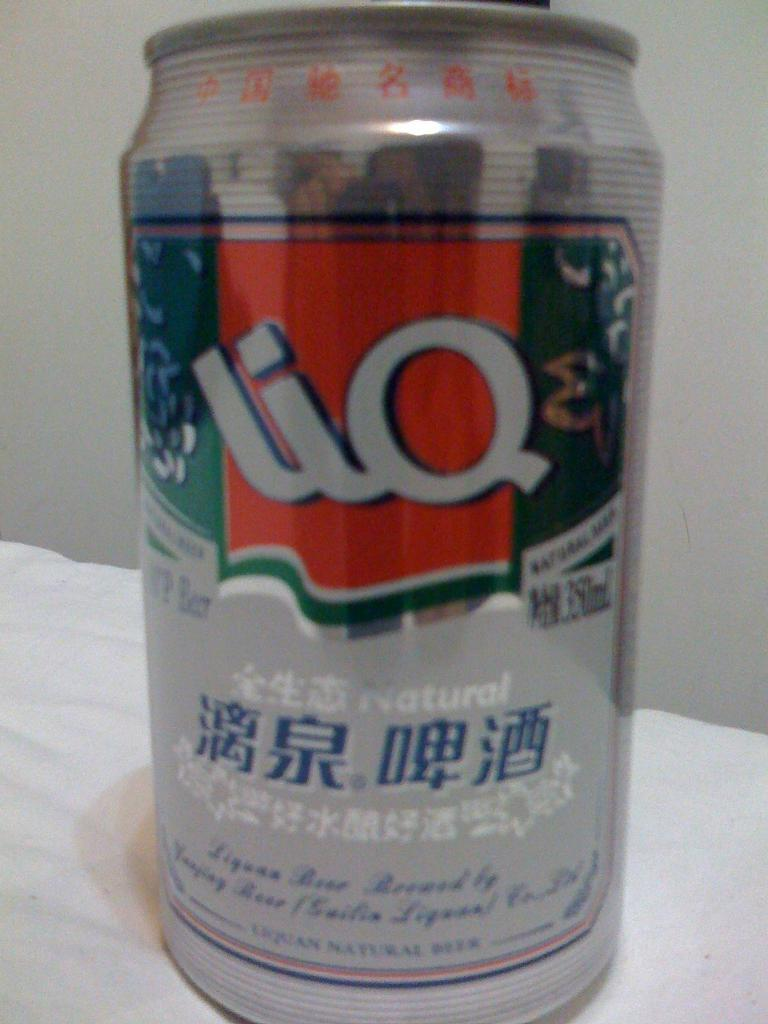<image>
Summarize the visual content of the image. a Lio can that is on a white surface 